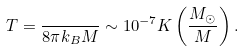Convert formula to latex. <formula><loc_0><loc_0><loc_500><loc_500>T = \frac { } { 8 \pi k _ { B } M } \sim 1 0 ^ { - 7 } K \left ( \frac { M _ { \odot } } { M } \right ) .</formula> 